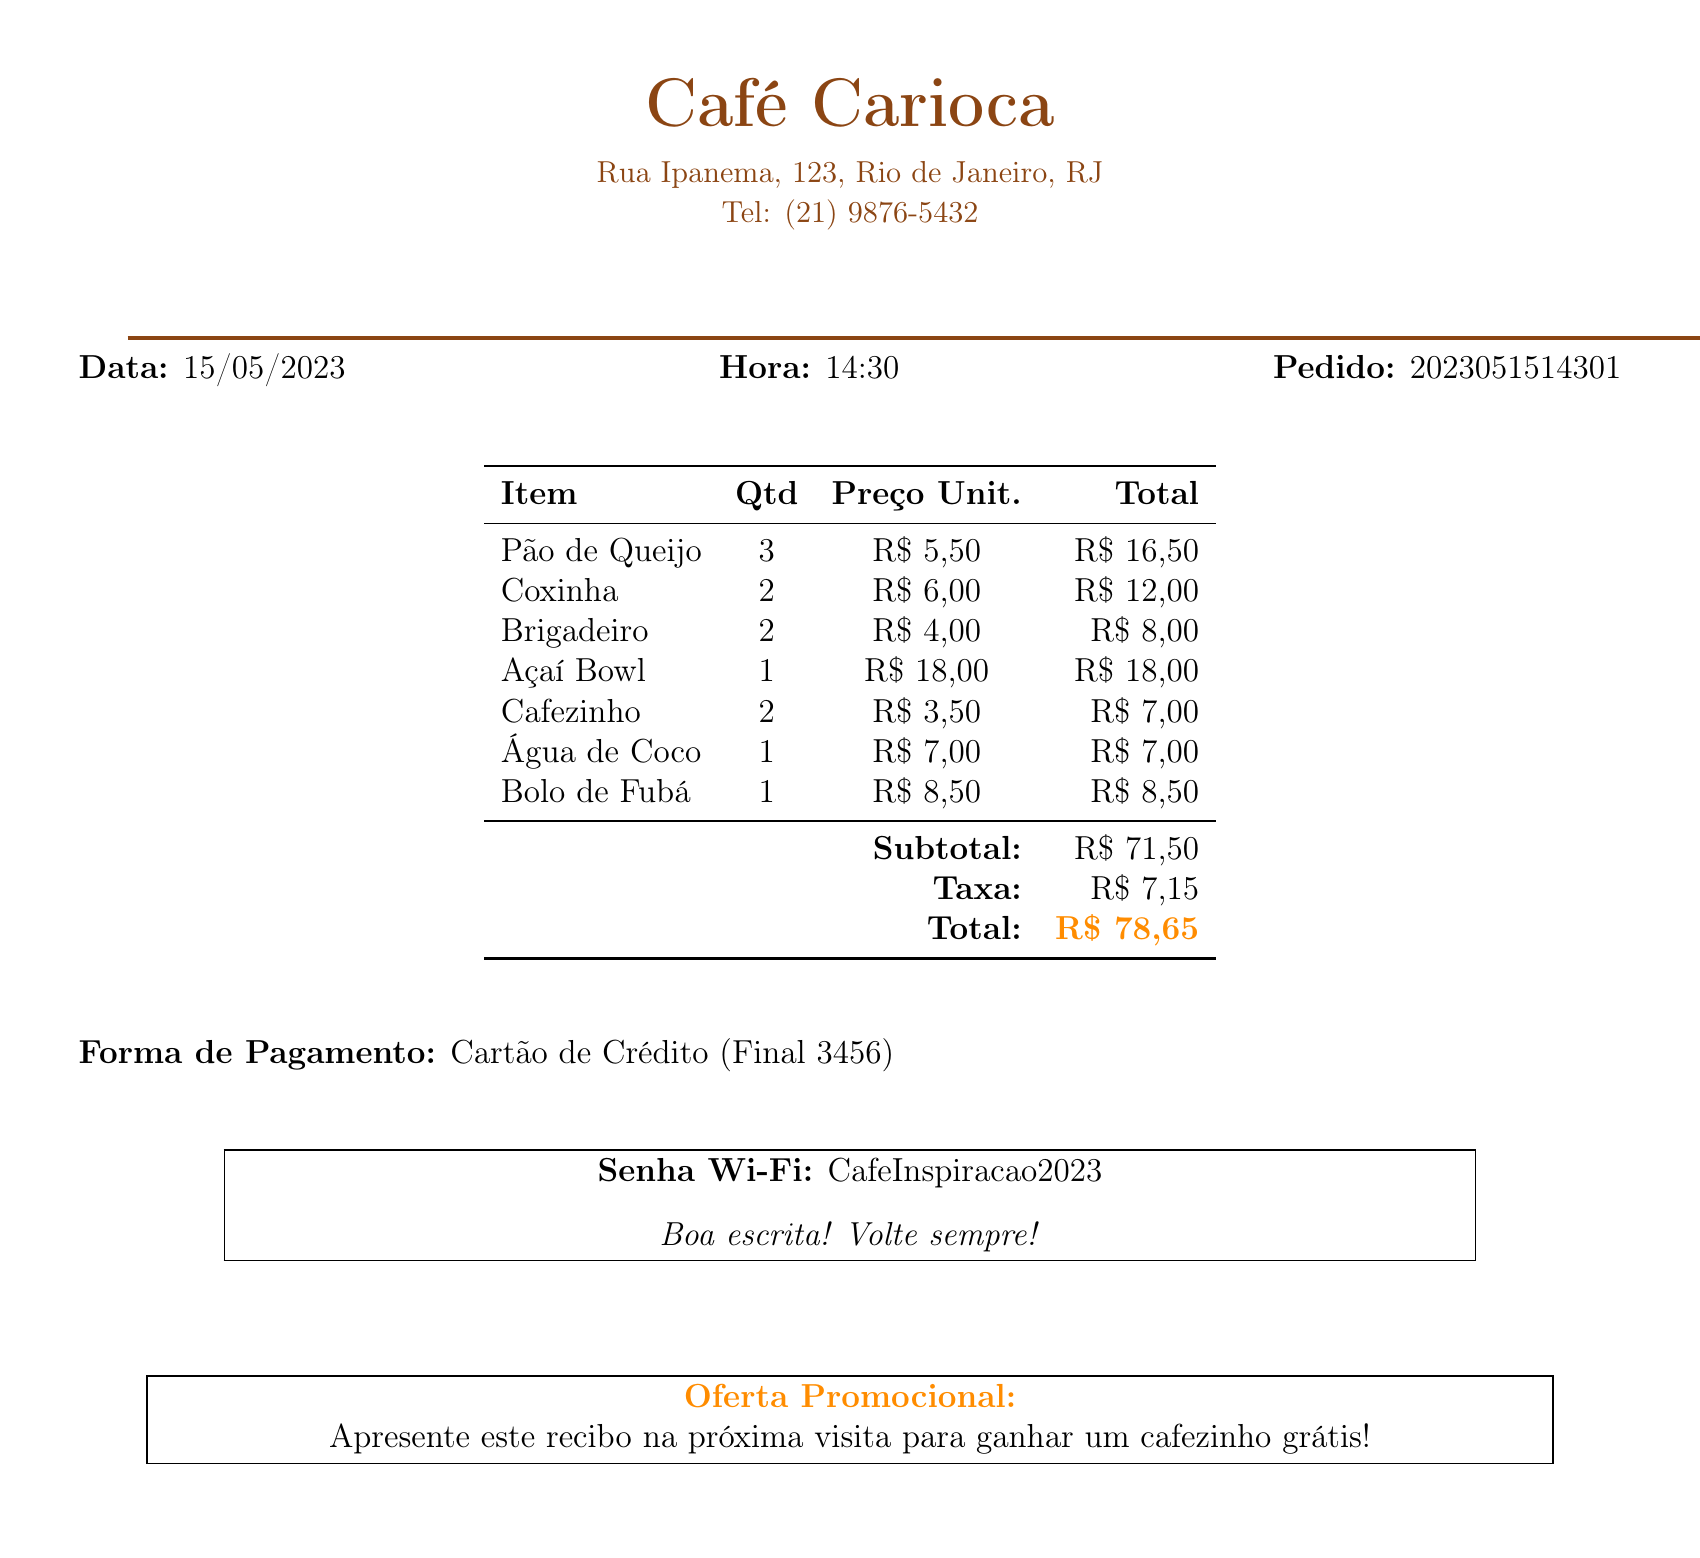what is the name of the café? The document identifies the café as "Café Carioca."
Answer: Café Carioca what is the address of the café? The address listed in the document is "Rua Ipanema, 123, Rio de Janeiro, RJ."
Answer: Rua Ipanema, 123, Rio de Janeiro, RJ what is the order number? The order number provided in the document is "2023051514301."
Answer: 2023051514301 how many Coxinhas were ordered? The document states that 2 Coxinhas were ordered.
Answer: 2 what is the total amount to be paid? The total amount listed in the document after tax is "R$ 78,65."
Answer: R$ 78,65 what is the payment method used? The document indicates the payment method as "Cartão de Crédito."
Answer: Cartão de Crédito what is the Wi-Fi password? The document provides the Wi-Fi password as "CafeInspiracao2023."
Answer: CafeInspiracao2023 what is the special note mentioned in the document? The special note says, "Boa escrita! Volte sempre!" expressing encouragement to writers.
Answer: Boa escrita! Volte sempre! what promotional offer is mentioned? The document mentions that the promotional offer is "Apresente este recibo na próxima visita para ganhar um cafezinho grátis!"
Answer: Apresente este recibo na próxima visita para ganhar um cafezinho grátis! 